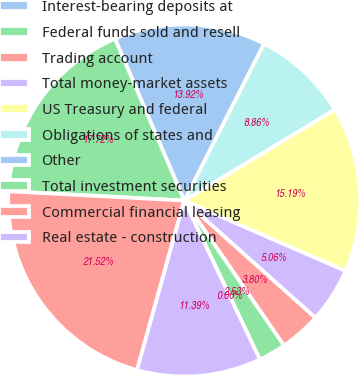Convert chart to OTSL. <chart><loc_0><loc_0><loc_500><loc_500><pie_chart><fcel>Interest-bearing deposits at<fcel>Federal funds sold and resell<fcel>Trading account<fcel>Total money-market assets<fcel>US Treasury and federal<fcel>Obligations of states and<fcel>Other<fcel>Total investment securities<fcel>Commercial financial leasing<fcel>Real estate - construction<nl><fcel>0.0%<fcel>2.53%<fcel>3.8%<fcel>5.06%<fcel>15.19%<fcel>8.86%<fcel>13.92%<fcel>17.72%<fcel>21.52%<fcel>11.39%<nl></chart> 